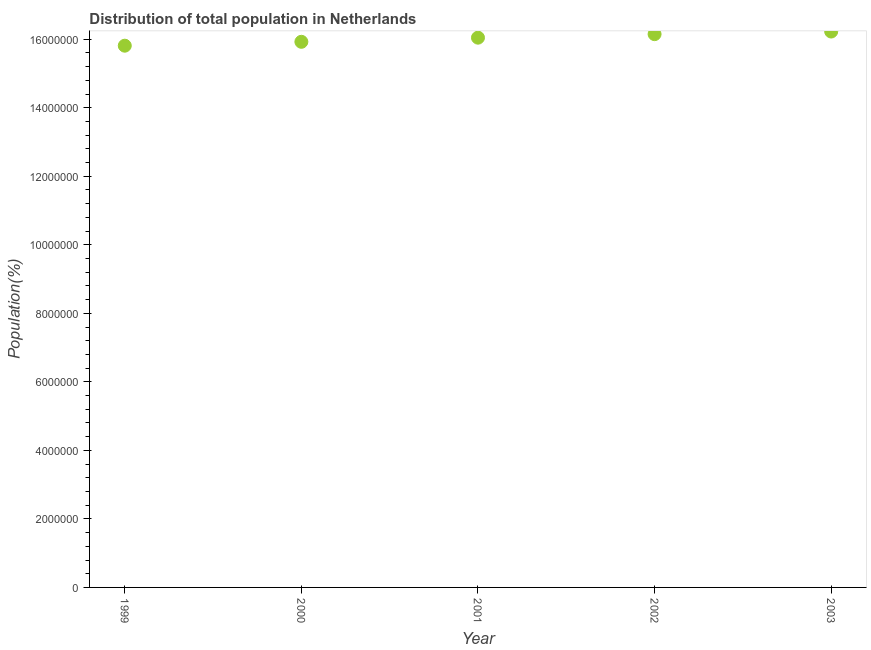What is the population in 1999?
Make the answer very short. 1.58e+07. Across all years, what is the maximum population?
Keep it short and to the point. 1.62e+07. Across all years, what is the minimum population?
Your answer should be very brief. 1.58e+07. In which year was the population maximum?
Keep it short and to the point. 2003. In which year was the population minimum?
Make the answer very short. 1999. What is the sum of the population?
Offer a very short reply. 8.02e+07. What is the difference between the population in 2000 and 2003?
Your response must be concise. -3.00e+05. What is the average population per year?
Your response must be concise. 1.60e+07. What is the median population?
Give a very brief answer. 1.60e+07. What is the ratio of the population in 2001 to that in 2003?
Provide a succinct answer. 0.99. Is the difference between the population in 2001 and 2003 greater than the difference between any two years?
Keep it short and to the point. No. What is the difference between the highest and the second highest population?
Your answer should be very brief. 7.64e+04. What is the difference between the highest and the lowest population?
Offer a very short reply. 4.13e+05. Does the population monotonically increase over the years?
Your answer should be very brief. Yes. How many dotlines are there?
Offer a very short reply. 1. How many years are there in the graph?
Provide a succinct answer. 5. What is the difference between two consecutive major ticks on the Y-axis?
Provide a succinct answer. 2.00e+06. Does the graph contain any zero values?
Offer a terse response. No. What is the title of the graph?
Your answer should be very brief. Distribution of total population in Netherlands . What is the label or title of the Y-axis?
Keep it short and to the point. Population(%). What is the Population(%) in 1999?
Your response must be concise. 1.58e+07. What is the Population(%) in 2000?
Your response must be concise. 1.59e+07. What is the Population(%) in 2001?
Make the answer very short. 1.60e+07. What is the Population(%) in 2002?
Offer a terse response. 1.61e+07. What is the Population(%) in 2003?
Offer a very short reply. 1.62e+07. What is the difference between the Population(%) in 1999 and 2000?
Offer a very short reply. -1.13e+05. What is the difference between the Population(%) in 1999 and 2001?
Give a very brief answer. -2.34e+05. What is the difference between the Population(%) in 1999 and 2002?
Your answer should be very brief. -3.37e+05. What is the difference between the Population(%) in 1999 and 2003?
Give a very brief answer. -4.13e+05. What is the difference between the Population(%) in 2000 and 2001?
Your response must be concise. -1.21e+05. What is the difference between the Population(%) in 2000 and 2002?
Your response must be concise. -2.23e+05. What is the difference between the Population(%) in 2000 and 2003?
Make the answer very short. -3.00e+05. What is the difference between the Population(%) in 2001 and 2002?
Provide a short and direct response. -1.03e+05. What is the difference between the Population(%) in 2001 and 2003?
Give a very brief answer. -1.79e+05. What is the difference between the Population(%) in 2002 and 2003?
Keep it short and to the point. -7.64e+04. What is the ratio of the Population(%) in 1999 to that in 2001?
Your answer should be compact. 0.98. What is the ratio of the Population(%) in 1999 to that in 2002?
Make the answer very short. 0.98. What is the ratio of the Population(%) in 2000 to that in 2001?
Provide a succinct answer. 0.99. 